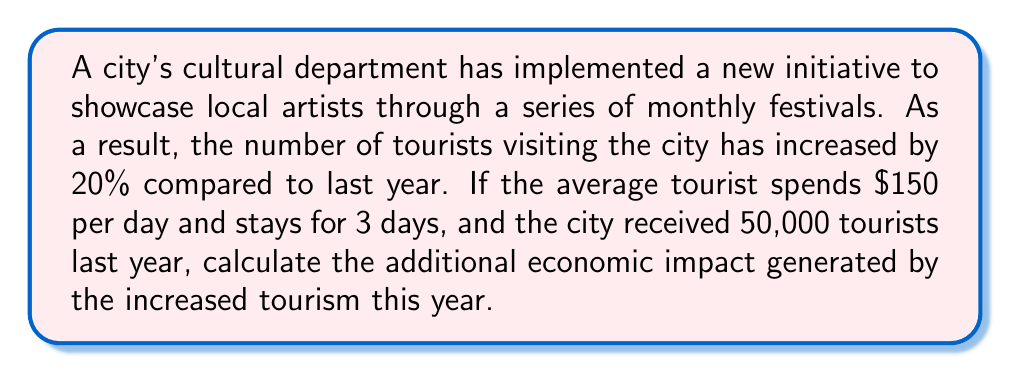Provide a solution to this math problem. Let's break this down step-by-step:

1. Calculate the number of tourists this year:
   Last year's tourists: 50,000
   Increase: 20% = 0.20
   Additional tourists: $50,000 \times 0.20 = 10,000$
   Total tourists this year: $50,000 + 10,000 = 60,000$

2. Calculate the increase in tourist numbers:
   $60,000 - 50,000 = 10,000$ additional tourists

3. Calculate the spending per tourist:
   Daily spending: $150
   Length of stay: 3 days
   Total spending per tourist: $150 \times 3 = $450$

4. Calculate the additional economic impact:
   Additional tourists: 10,000
   Spending per tourist: $450
   
   Total additional economic impact:
   $$10,000 \times $450 = $4,500,000$$

Therefore, the additional economic impact generated by the increased tourism due to the cultural initiatives is $4,500,000.
Answer: $4,500,000 